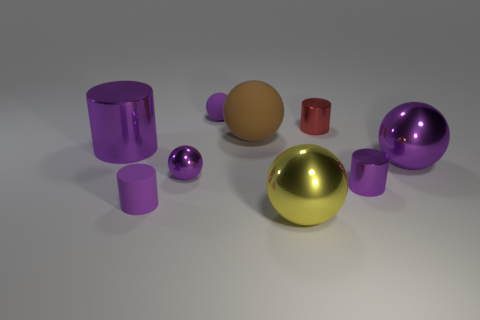The rubber thing that is on the left side of the small shiny sphere has what shape? cylinder 